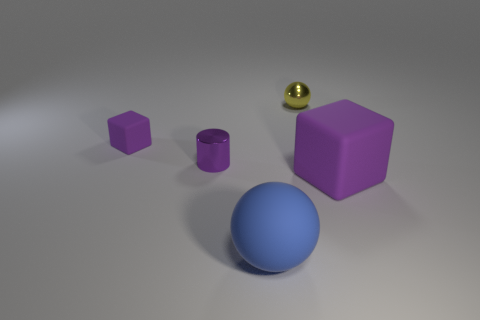Do the object in front of the large block and the matte cube on the right side of the purple shiny object have the same color?
Keep it short and to the point. No. What shape is the rubber object that is behind the big ball and on the left side of the yellow shiny sphere?
Offer a terse response. Cube. Is there a tiny yellow shiny object of the same shape as the big blue matte thing?
Make the answer very short. Yes. The purple thing that is the same size as the matte sphere is what shape?
Offer a very short reply. Cube. What is the tiny cube made of?
Your response must be concise. Rubber. There is a purple matte block that is to the left of the purple metallic cylinder that is to the left of the tiny thing on the right side of the blue rubber thing; what size is it?
Provide a succinct answer. Small. There is a tiny cube that is the same color as the big block; what is its material?
Your response must be concise. Rubber. How many metal objects are tiny balls or large yellow cylinders?
Your answer should be very brief. 1. The cylinder is what size?
Your answer should be very brief. Small. How many things are either tiny blue matte cubes or small things that are on the left side of the blue rubber sphere?
Your answer should be compact. 2. 